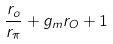<formula> <loc_0><loc_0><loc_500><loc_500>\frac { r _ { o } } { r _ { \pi } } + g _ { m } r _ { O } + 1</formula> 